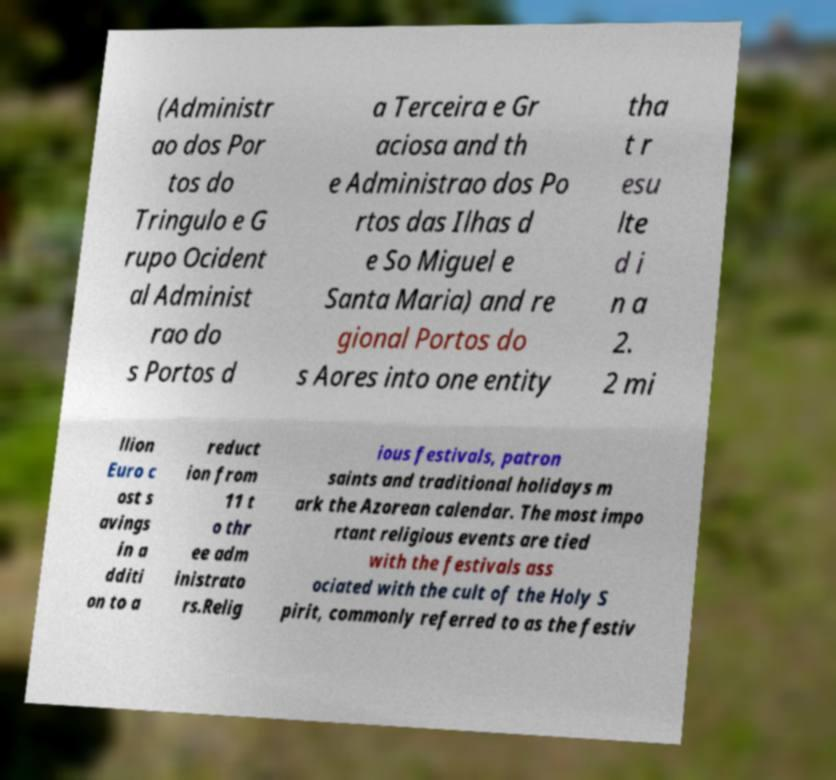For documentation purposes, I need the text within this image transcribed. Could you provide that? (Administr ao dos Por tos do Tringulo e G rupo Ocident al Administ rao do s Portos d a Terceira e Gr aciosa and th e Administrao dos Po rtos das Ilhas d e So Miguel e Santa Maria) and re gional Portos do s Aores into one entity tha t r esu lte d i n a 2. 2 mi llion Euro c ost s avings in a dditi on to a reduct ion from 11 t o thr ee adm inistrato rs.Relig ious festivals, patron saints and traditional holidays m ark the Azorean calendar. The most impo rtant religious events are tied with the festivals ass ociated with the cult of the Holy S pirit, commonly referred to as the festiv 